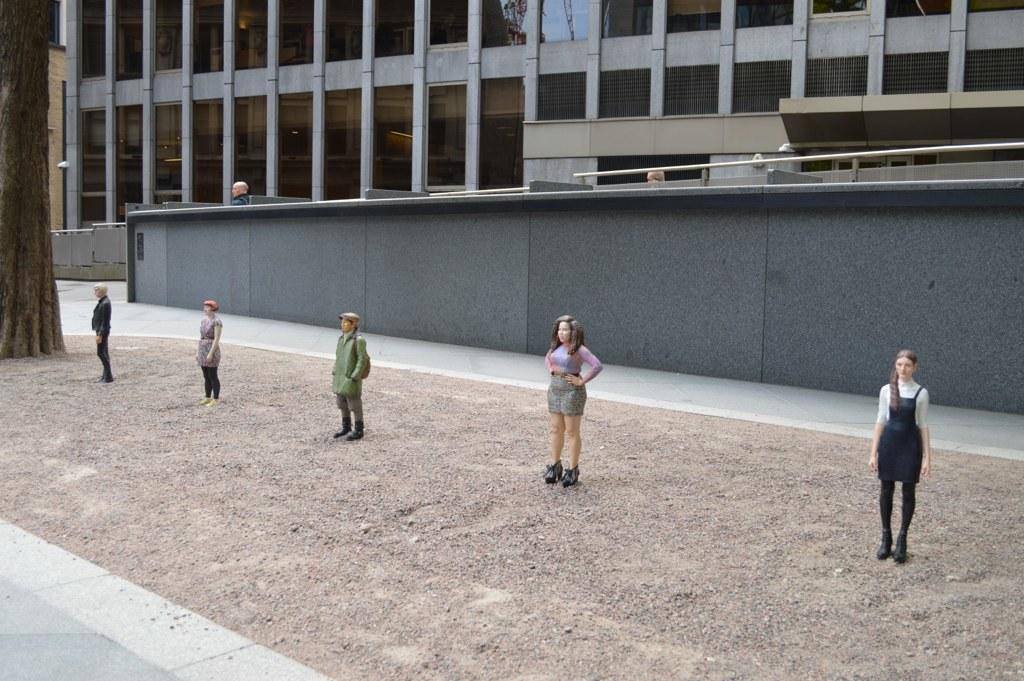How would you summarize this image in a sentence or two? In this picture I see the statues of the person which are standing on the ground. In the back I can see the building. On the left there is a tree, beside that I can see the street lights. Behind the walls I can see some people were standing. 